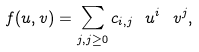<formula> <loc_0><loc_0><loc_500><loc_500>f ( u , v ) = \sum _ { j , j \geq 0 } c _ { i , j } \ u ^ { i } \ v ^ { j } ,</formula> 